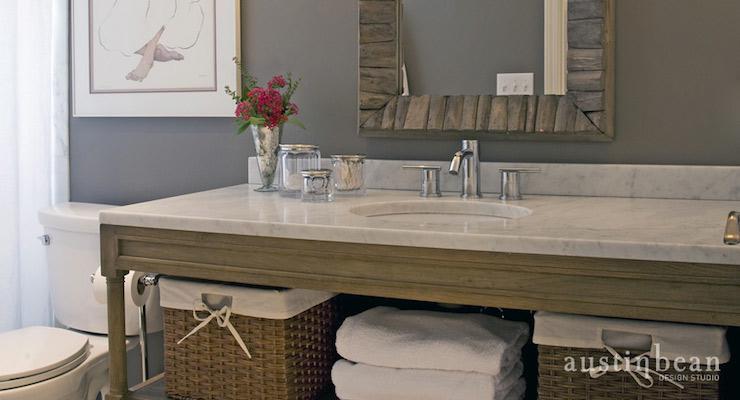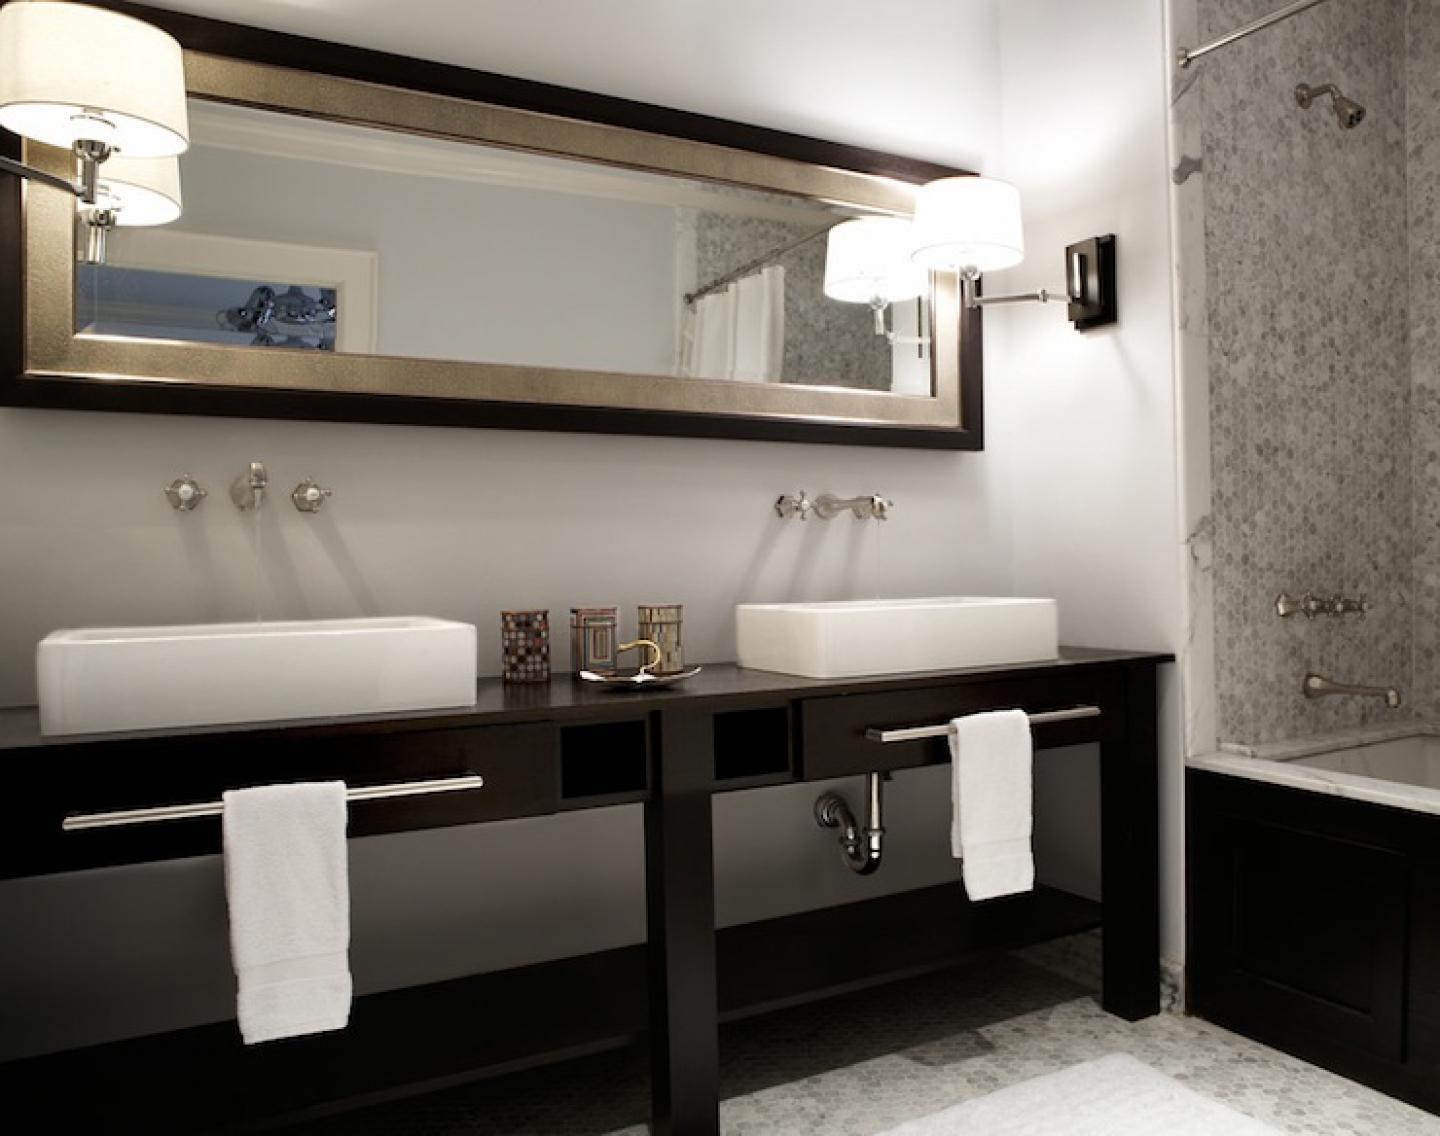The first image is the image on the left, the second image is the image on the right. Evaluate the accuracy of this statement regarding the images: "The vanity in the right-hand image features a pair of squarish white basins sitting on top.". Is it true? Answer yes or no. Yes. The first image is the image on the left, the second image is the image on the right. Considering the images on both sides, is "In one image, one large mirror is positioned over a long open wooden vanity on feet with two matching white sinks." valid? Answer yes or no. Yes. 